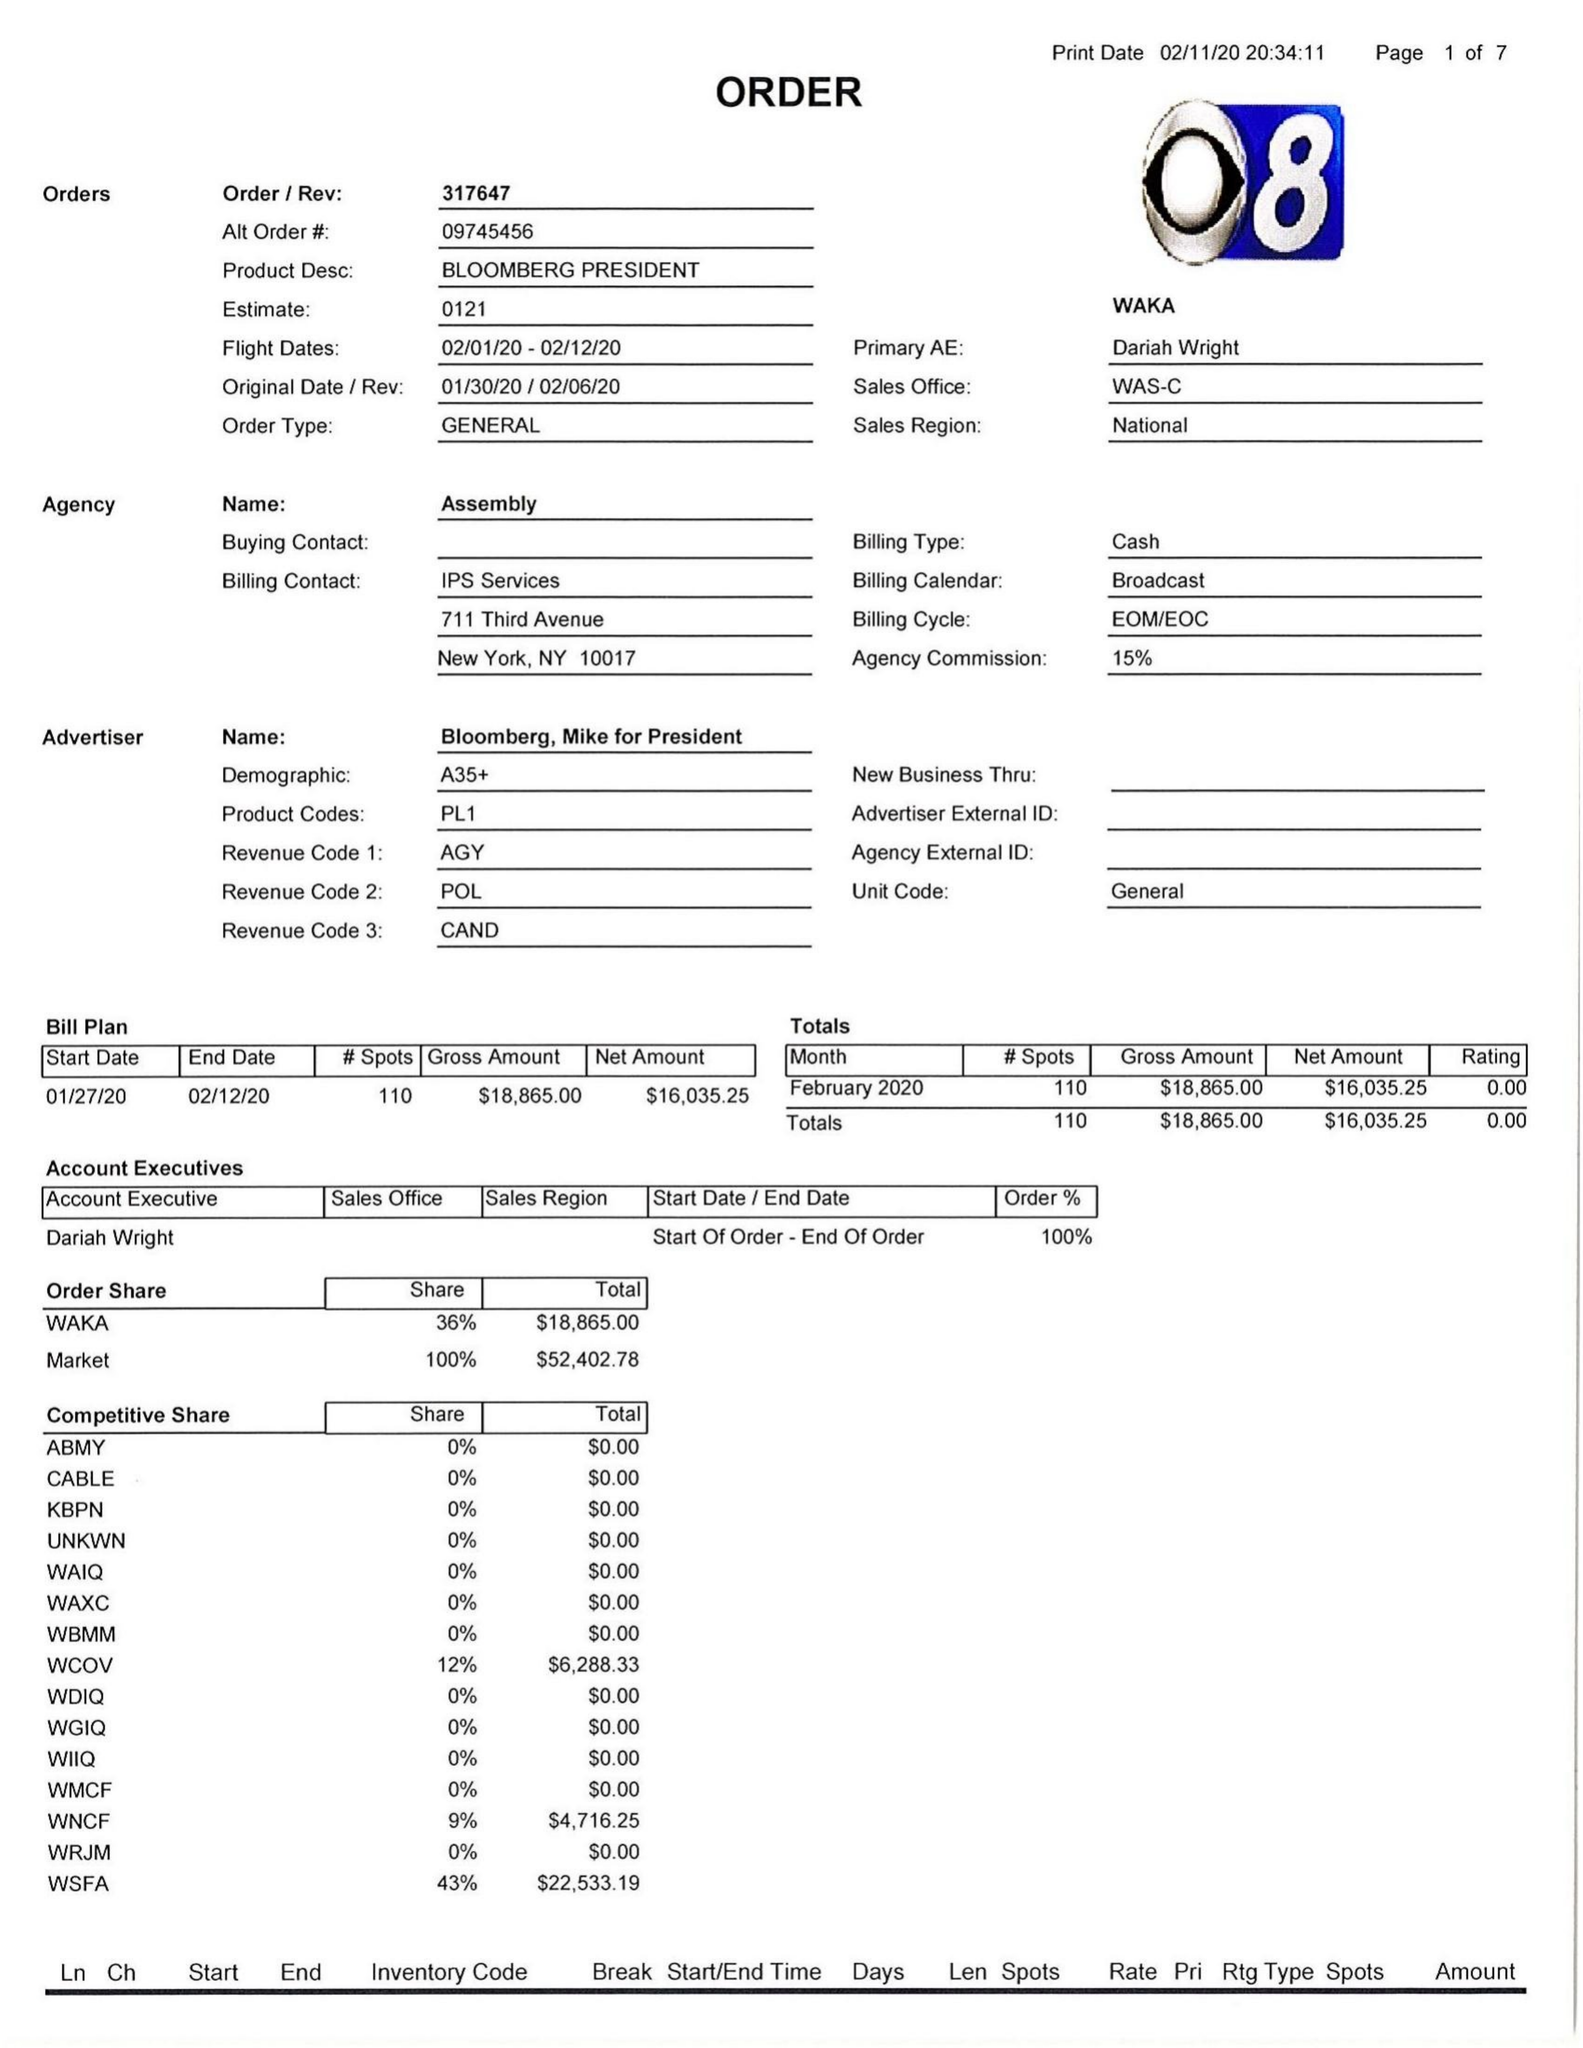What is the value for the advertiser?
Answer the question using a single word or phrase. BLOOMBERG, MIKE FOR PRESIDENT 